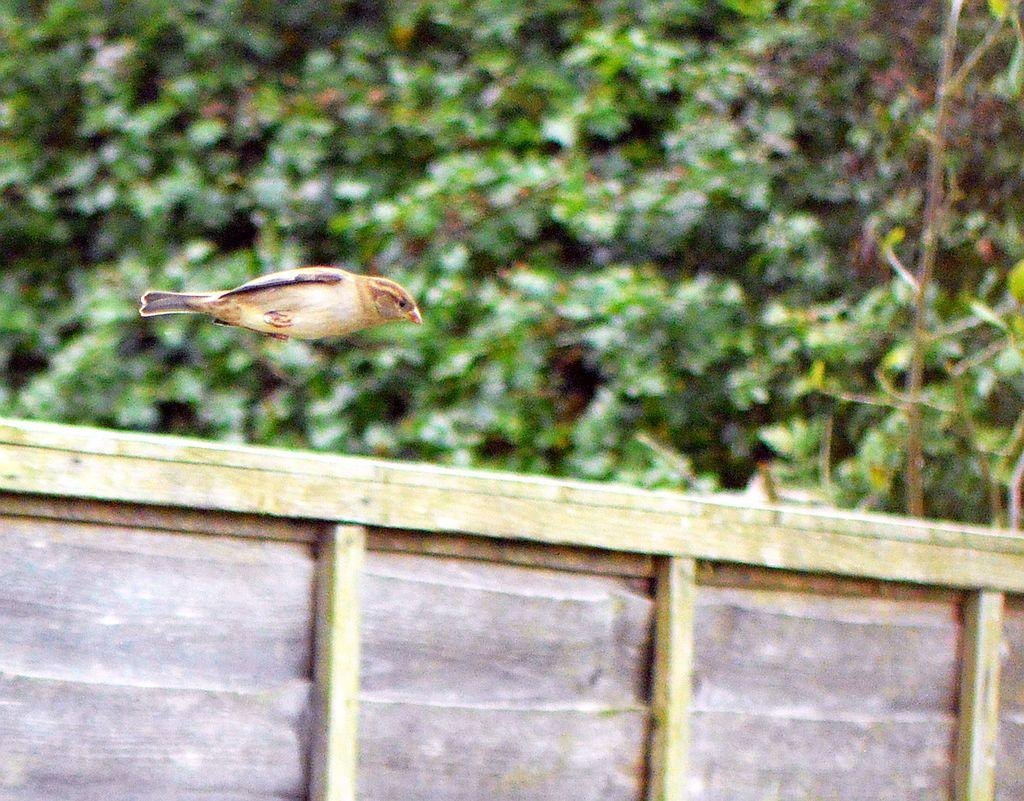What is the main subject of the image? There is a bird flying in the image. What can be seen in the background of the image? There is greenery visible in the background of the image. What is at the bottom of the image? There is a boundary wall at the bottom of the image. Can you tell me what type of cake the monkey is eating in the image? There is no monkey or cake present in the image. 